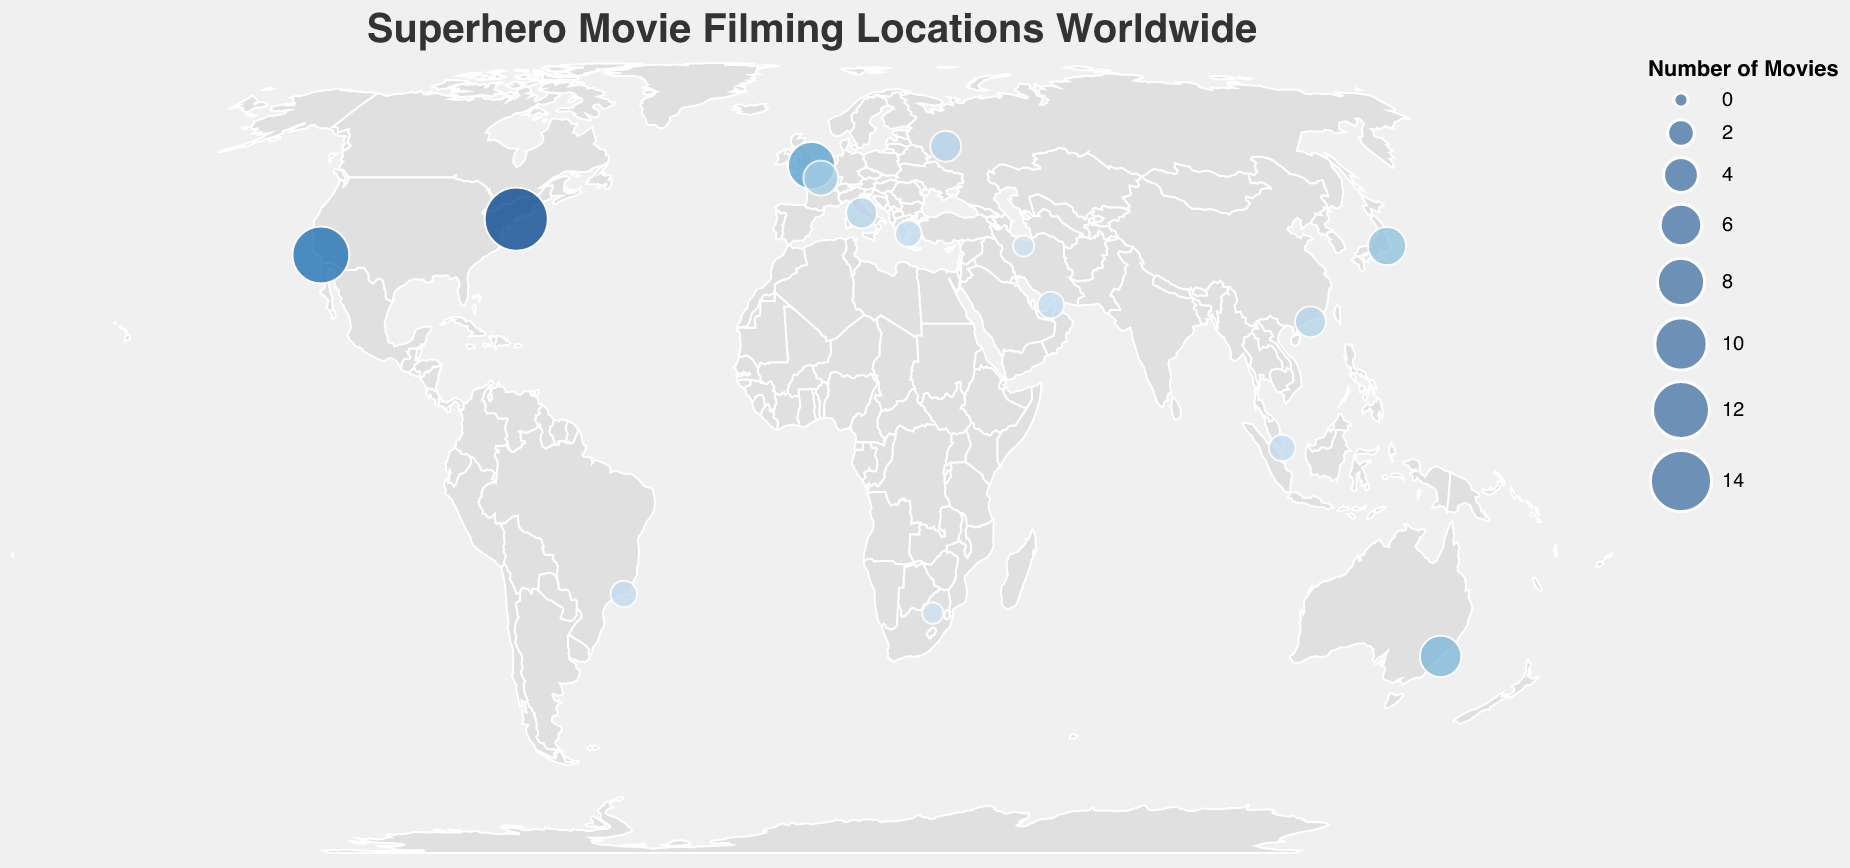What's the most frequent filming location? By examining the size and color of the circles, the largest and darkest circle represents the most frequent location, which is New York City.
Answer: New York City Which city has the highest number of superhero movies filmed? The city with the highest number is represented by the largest circle. In the figure, New York City has the largest circle with a frequency of 15.
Answer: New York City What city is represented by the smallest circle? The smallest circles are those with a frequency of 1, represented by Johannesburg and Tehran.
Answer: Johannesburg and Tehran How many cities have a filming frequency of 2? Looking for circles that are mid-sized and moderately colored can help identify cities with a frequency of 2. There are four cities: Rio de Janeiro, Singapore, Dubai, and Athens.
Answer: Four Compare the number of movies filmed in Los Angeles and London. Which one has more? By checking the size of the circles for both cities, Los Angeles has a frequency of 12 while London has a frequency of 8. Therefore, Los Angeles has more.
Answer: Los Angeles What is the combined number of movies filmed in Sydney, Tokyo, and Paris? The frequencies for these cities are 6, 5, and 4 respectively. Adding them up: 6 + 5 + 4 = 15.
Answer: 15 Which continent has the highest concentration of superhero movie filming locations? By analyzing the geographic distribution of the circles, North America has the highest concentration with key locations in New York City and Los Angeles.
Answer: North America Identify the cities with equal filming frequencies of 3. By locating the cities with circles of similar sizes representing a frequency of 3, they are Rome, Moscow, and Hong Kong.
Answer: Rome, Moscow, and Hong Kong What is the total number of unique filming locations shown in the plot? Counting all distinct data points on the map, there are 15 unique filming locations.
Answer: 15 Which movie has the most frequent filming location in New York City? The tooltip can be used here: hovering over New York City will reveal the featured movie and frequency. The movie is Spider-Man with a frequency of 15.
Answer: Spider-Man 